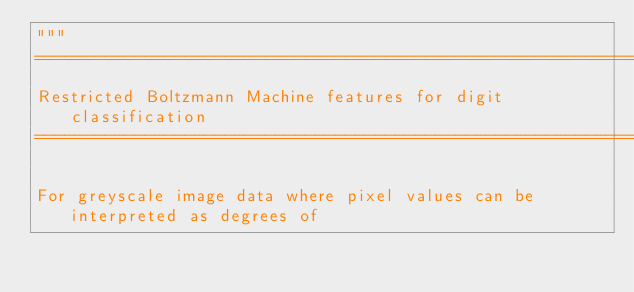<code> <loc_0><loc_0><loc_500><loc_500><_Python_>"""
==============================================================
Restricted Boltzmann Machine features for digit classification
==============================================================

For greyscale image data where pixel values can be interpreted as degrees of</code> 